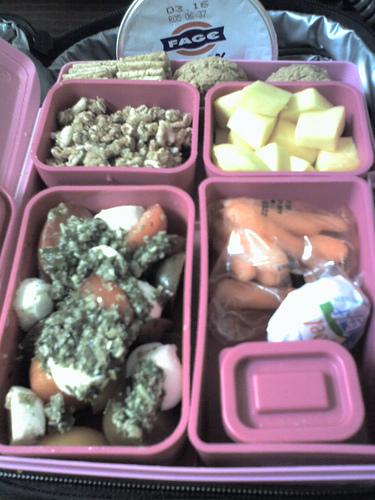What color are the containers?
Be succinct. Pink. Is there any broccoli in this photo?
Answer briefly. No. What is the yogurt brand?
Give a very brief answer. Fage. Are these cake?
Write a very short answer. No. 